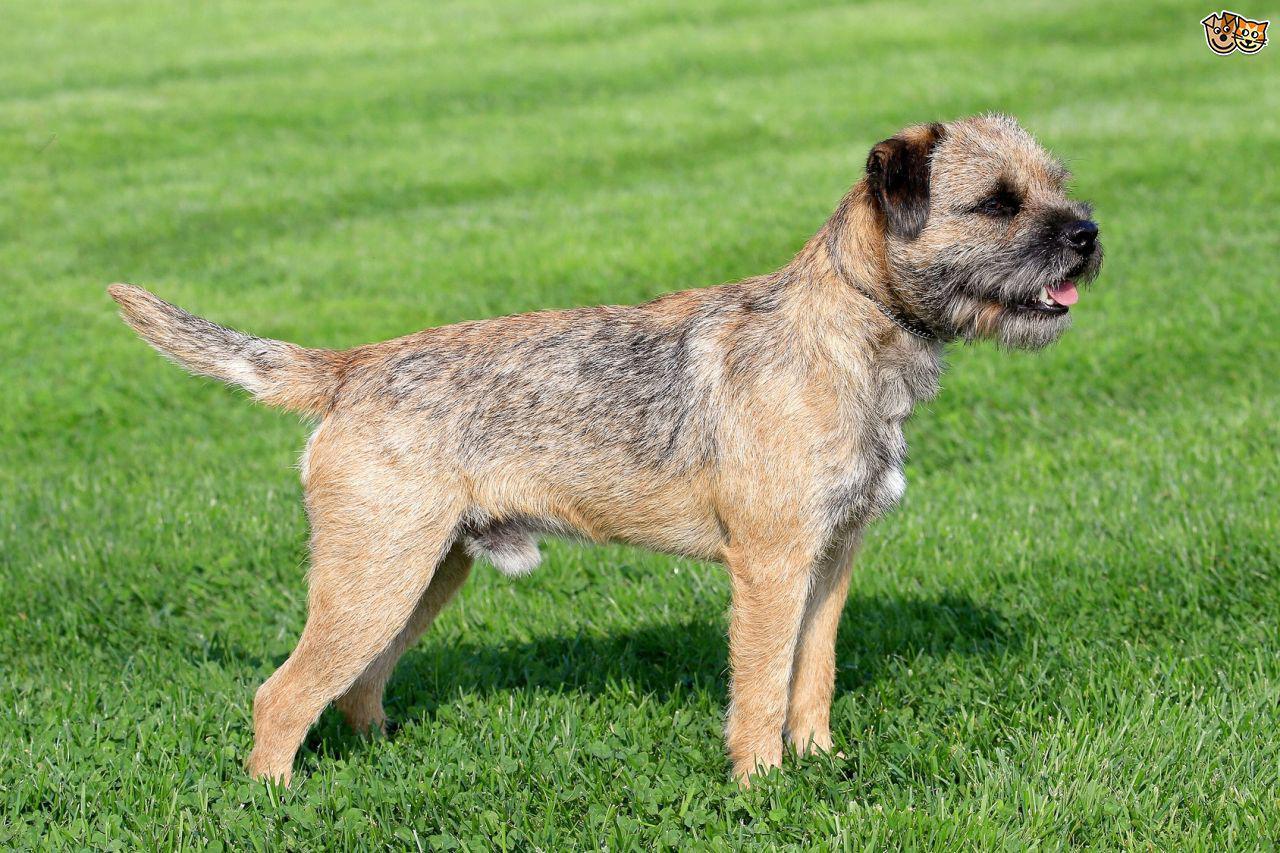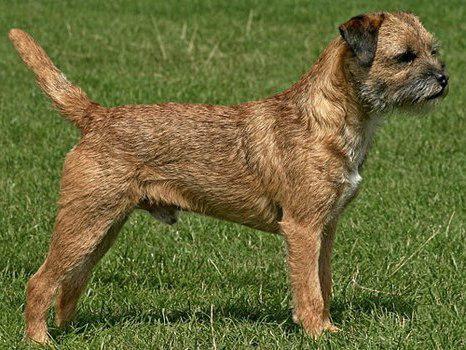The first image is the image on the left, the second image is the image on the right. Given the left and right images, does the statement "The dog on the left is standing in the grass by a person." hold true? Answer yes or no. No. The first image is the image on the left, the second image is the image on the right. Assess this claim about the two images: "Both images show dogs standing in profile with bodies and heads turned the same direction.". Correct or not? Answer yes or no. Yes. 